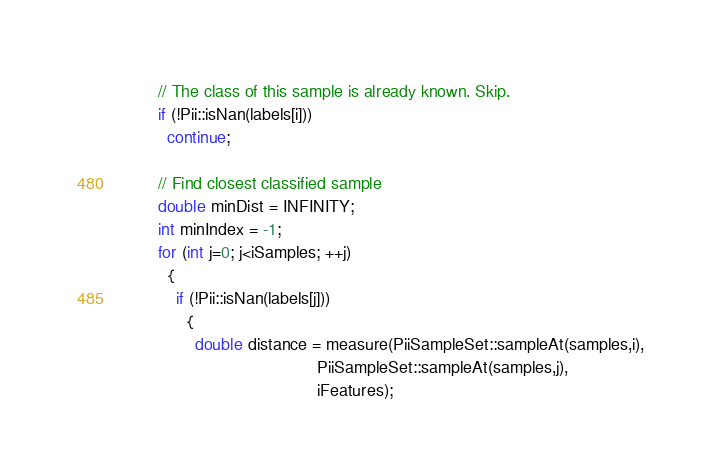Convert code to text. <code><loc_0><loc_0><loc_500><loc_500><_C_>        // The class of this sample is already known. Skip.
        if (!Pii::isNan(labels[i]))
          continue;

        // Find closest classified sample
        double minDist = INFINITY;
        int minIndex = -1;
        for (int j=0; j<iSamples; ++j)
          {
            if (!Pii::isNan(labels[j]))
              {
                double distance = measure(PiiSampleSet::sampleAt(samples,i),
                                          PiiSampleSet::sampleAt(samples,j),
                                          iFeatures);</code> 